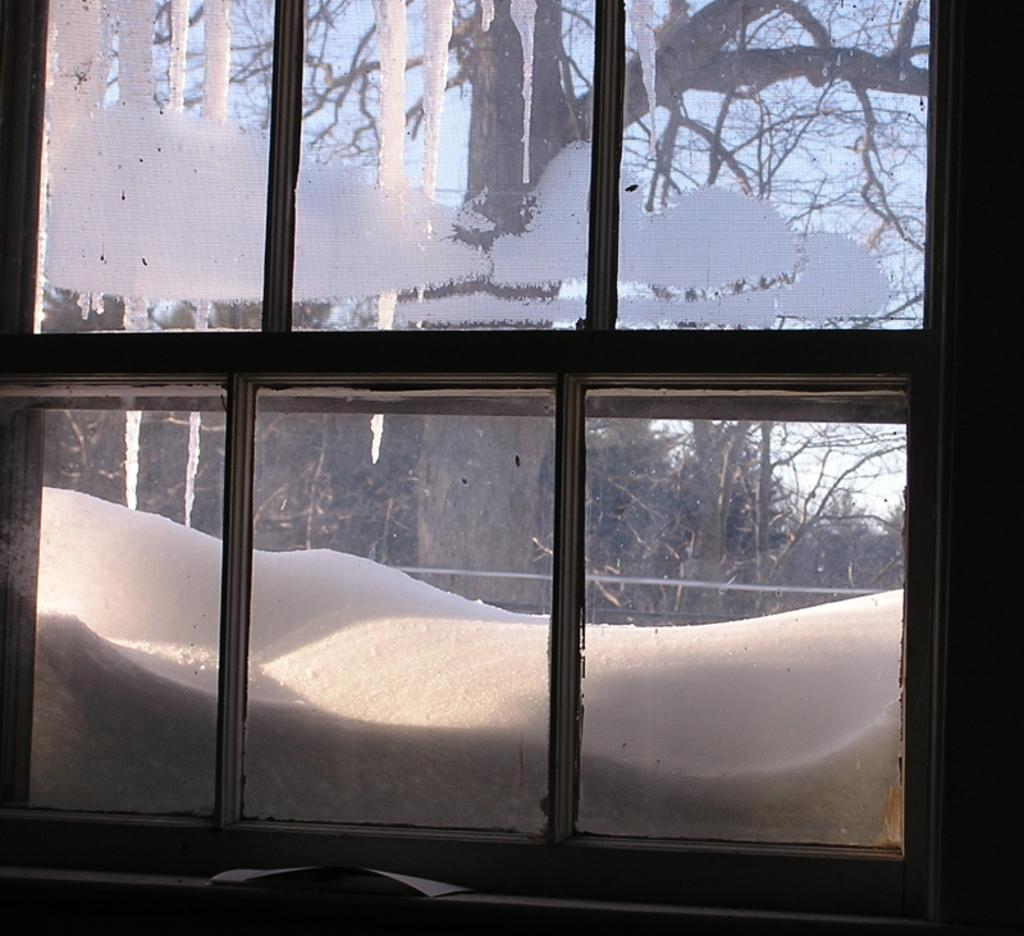What type of structure is present in the image? There is a glass window in the image. What can be seen through the window? Snow and trees are visible through the window. What type of invention is being demonstrated through the window in the image? There is no invention being demonstrated through the window in the image; it simply shows snow and trees. Who is the governor of the area visible through the window in the image? There is no information about a governor or any political figures in the image. 